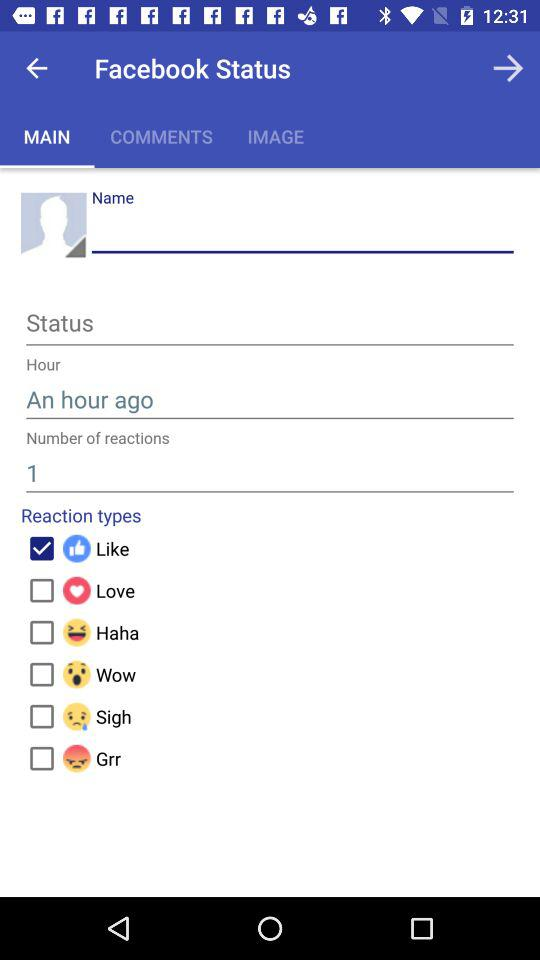What is the status of "Like"? The status is "on". 